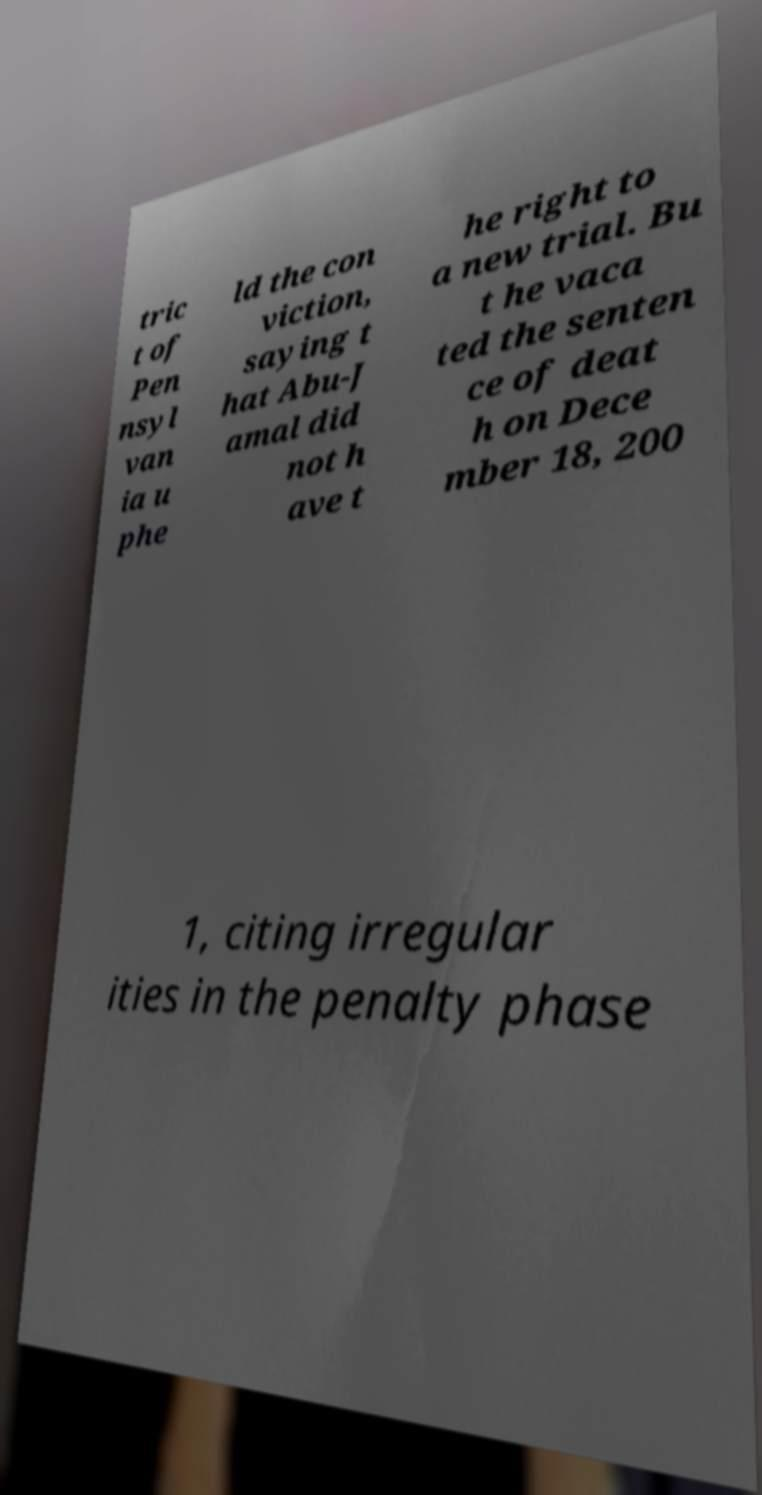There's text embedded in this image that I need extracted. Can you transcribe it verbatim? tric t of Pen nsyl van ia u phe ld the con viction, saying t hat Abu-J amal did not h ave t he right to a new trial. Bu t he vaca ted the senten ce of deat h on Dece mber 18, 200 1, citing irregular ities in the penalty phase 